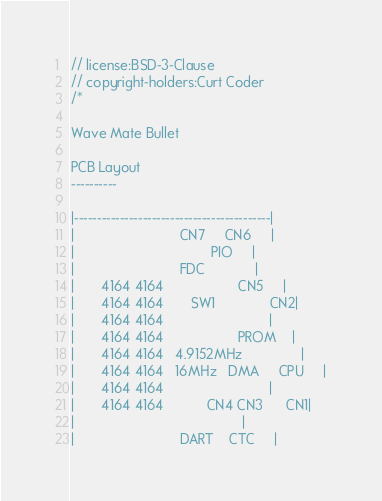Convert code to text. <code><loc_0><loc_0><loc_500><loc_500><_C++_>// license:BSD-3-Clause
// copyright-holders:Curt Coder
/*

Wave Mate Bullet

PCB Layout
----------

|-------------------------------------------|
|                           CN7     CN6     |
|                                   PIO     |
|                           FDC             |
|       4164 4164                   CN5     |
|       4164 4164       SW1              CN2|
|       4164 4164                           |
|       4164 4164                   PROM    |
|       4164 4164   4.9152MHz               |
|       4164 4164   16MHz   DMA     CPU     |
|       4164 4164                           |
|       4164 4164           CN4 CN3      CN1|
|                                           |
|                           DART    CTC     |</code> 